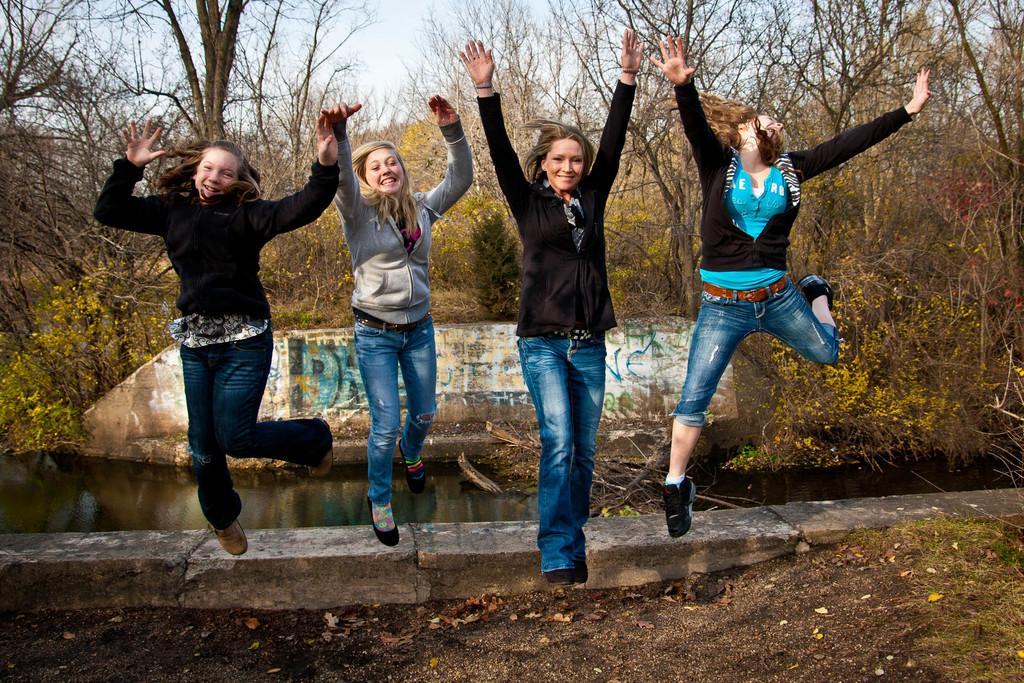How would you summarize this image in a sentence or two? In this picture I can see four women are smiling. In the background I can see water, trees and the sky. Here I can see grass and plants. 